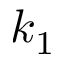<formula> <loc_0><loc_0><loc_500><loc_500>k _ { 1 }</formula> 